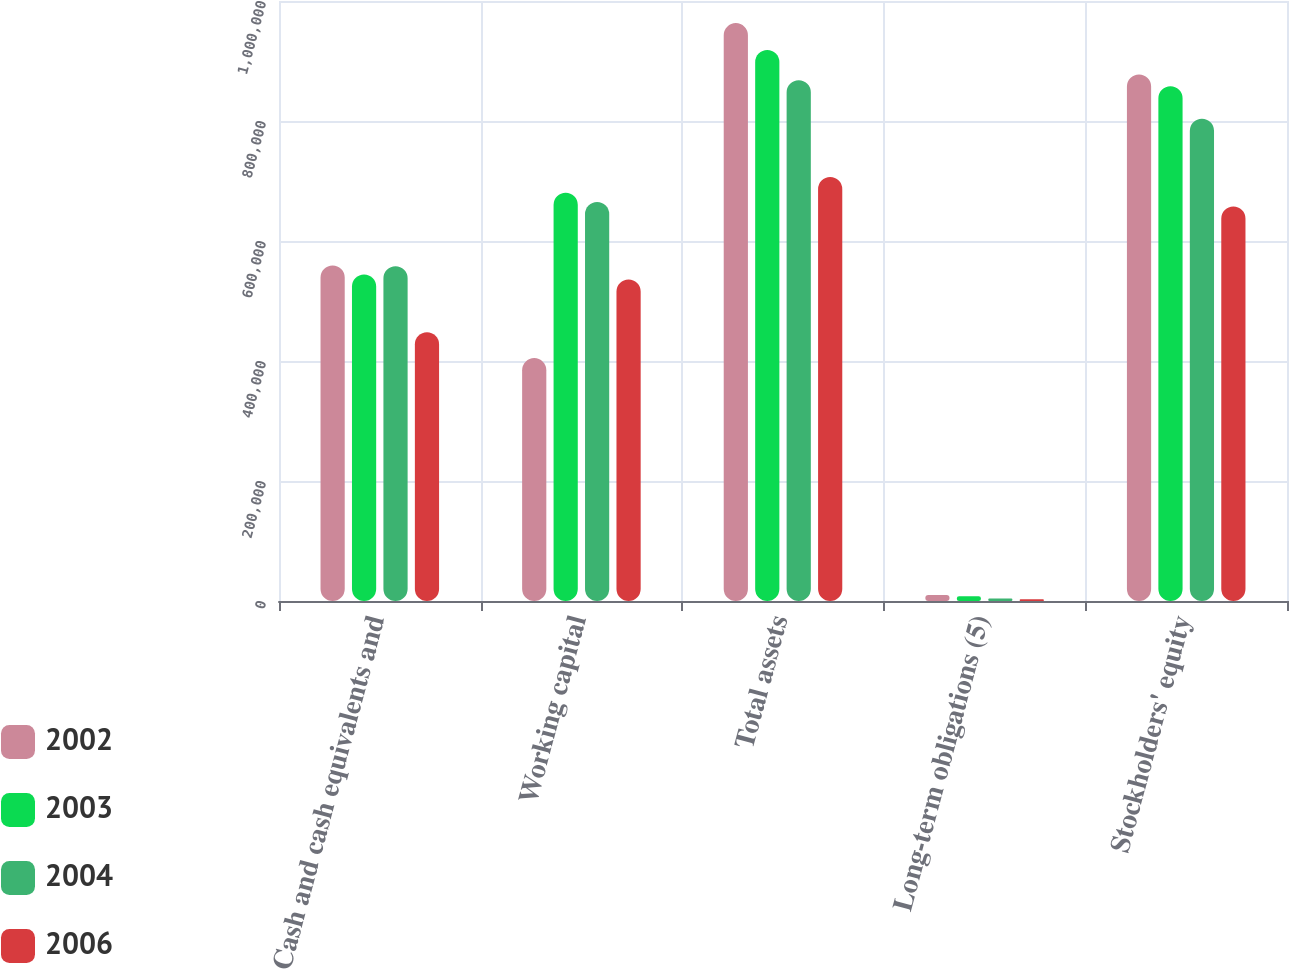<chart> <loc_0><loc_0><loc_500><loc_500><stacked_bar_chart><ecel><fcel>Cash and cash equivalents and<fcel>Working capital<fcel>Total assets<fcel>Long-term obligations (5)<fcel>Stockholders' equity<nl><fcel>2002<fcel>559189<fcel>404836<fcel>963142<fcel>9969<fcel>877681<nl><fcel>2003<fcel>544239<fcel>680554<fcel>918415<fcel>7709<fcel>857972<nl><fcel>2004<fcel>557993<fcel>665062<fcel>868044<fcel>4011<fcel>803893<nl><fcel>2006<fcel>447848<fcel>535816<fcel>706530<fcel>2853<fcel>657557<nl></chart> 